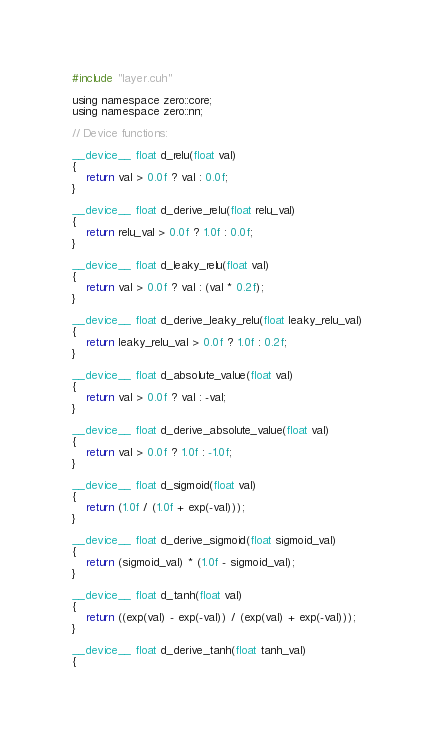<code> <loc_0><loc_0><loc_500><loc_500><_Cuda_>#include "layer.cuh"

using namespace zero::core;
using namespace zero::nn;

// Device functions:

__device__ float d_relu(float val)
{
    return val > 0.0f ? val : 0.0f;
}

__device__ float d_derive_relu(float relu_val)
{
    return relu_val > 0.0f ? 1.0f : 0.0f;
}

__device__ float d_leaky_relu(float val)
{
    return val > 0.0f ? val : (val * 0.2f);
}

__device__ float d_derive_leaky_relu(float leaky_relu_val)
{
    return leaky_relu_val > 0.0f ? 1.0f : 0.2f;
}

__device__ float d_absolute_value(float val)
{
    return val > 0.0f ? val : -val;
}

__device__ float d_derive_absolute_value(float val)
{
    return val > 0.0f ? 1.0f : -1.0f;
}

__device__ float d_sigmoid(float val)
{
    return (1.0f / (1.0f + exp(-val)));
}

__device__ float d_derive_sigmoid(float sigmoid_val)
{
    return (sigmoid_val) * (1.0f - sigmoid_val);
}

__device__ float d_tanh(float val)
{
    return ((exp(val) - exp(-val)) / (exp(val) + exp(-val)));
}

__device__ float d_derive_tanh(float tanh_val)
{</code> 